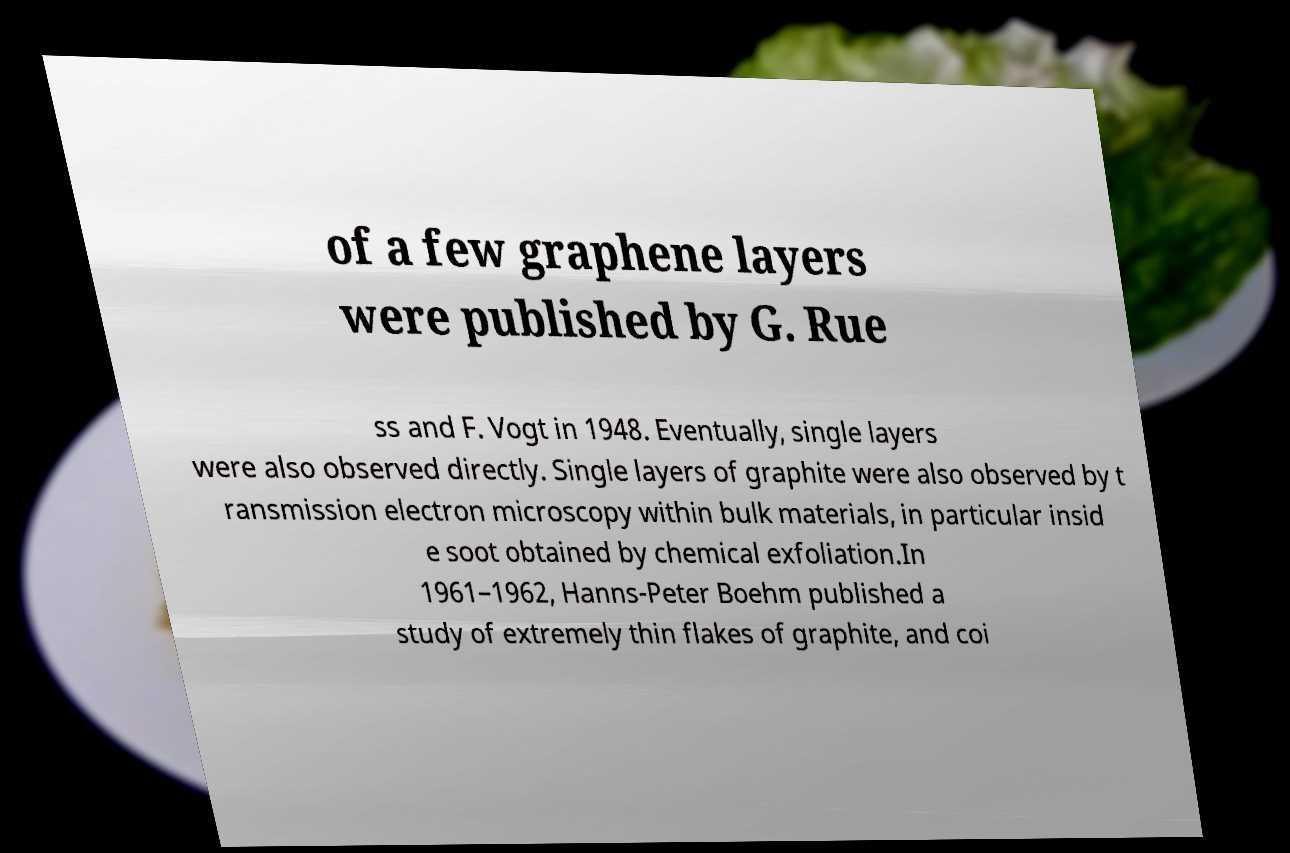Could you assist in decoding the text presented in this image and type it out clearly? of a few graphene layers were published by G. Rue ss and F. Vogt in 1948. Eventually, single layers were also observed directly. Single layers of graphite were also observed by t ransmission electron microscopy within bulk materials, in particular insid e soot obtained by chemical exfoliation.In 1961–1962, Hanns-Peter Boehm published a study of extremely thin flakes of graphite, and coi 